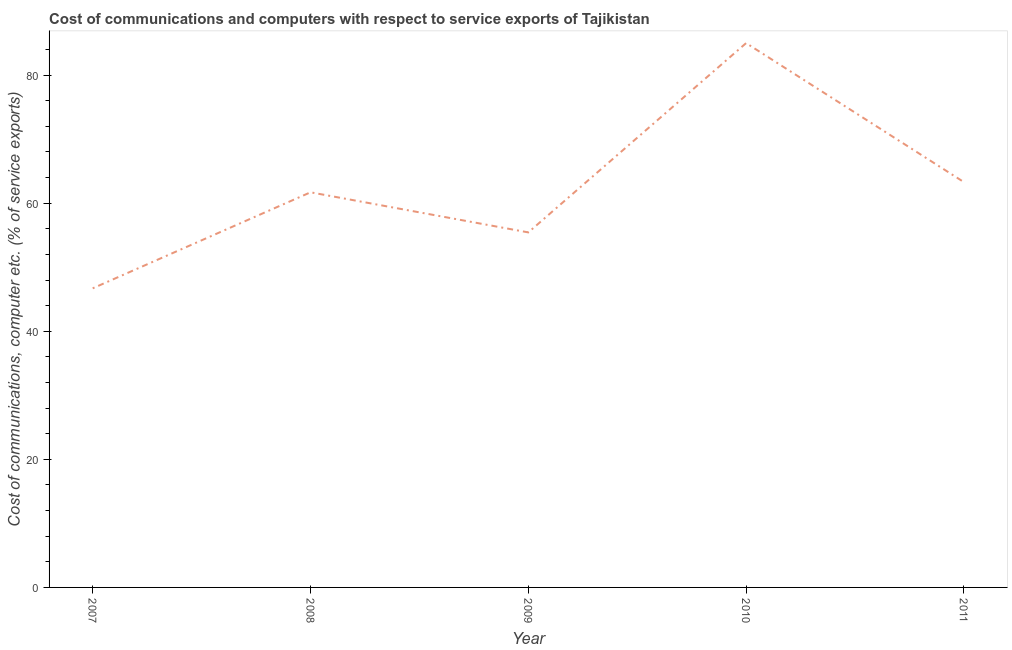What is the cost of communications and computer in 2010?
Keep it short and to the point. 84.99. Across all years, what is the maximum cost of communications and computer?
Your response must be concise. 84.99. Across all years, what is the minimum cost of communications and computer?
Make the answer very short. 46.7. In which year was the cost of communications and computer minimum?
Your answer should be compact. 2007. What is the sum of the cost of communications and computer?
Keep it short and to the point. 312.11. What is the difference between the cost of communications and computer in 2008 and 2010?
Offer a very short reply. -23.3. What is the average cost of communications and computer per year?
Your answer should be very brief. 62.42. What is the median cost of communications and computer?
Your answer should be very brief. 61.69. Do a majority of the years between 2011 and 2007 (inclusive) have cost of communications and computer greater than 12 %?
Make the answer very short. Yes. What is the ratio of the cost of communications and computer in 2007 to that in 2010?
Offer a terse response. 0.55. What is the difference between the highest and the second highest cost of communications and computer?
Your response must be concise. 21.71. Is the sum of the cost of communications and computer in 2008 and 2009 greater than the maximum cost of communications and computer across all years?
Give a very brief answer. Yes. What is the difference between the highest and the lowest cost of communications and computer?
Offer a terse response. 38.29. In how many years, is the cost of communications and computer greater than the average cost of communications and computer taken over all years?
Your response must be concise. 2. How many lines are there?
Give a very brief answer. 1. What is the difference between two consecutive major ticks on the Y-axis?
Make the answer very short. 20. Are the values on the major ticks of Y-axis written in scientific E-notation?
Make the answer very short. No. Does the graph contain any zero values?
Give a very brief answer. No. Does the graph contain grids?
Offer a very short reply. No. What is the title of the graph?
Your response must be concise. Cost of communications and computers with respect to service exports of Tajikistan. What is the label or title of the X-axis?
Your answer should be compact. Year. What is the label or title of the Y-axis?
Your answer should be compact. Cost of communications, computer etc. (% of service exports). What is the Cost of communications, computer etc. (% of service exports) in 2007?
Your answer should be very brief. 46.7. What is the Cost of communications, computer etc. (% of service exports) of 2008?
Provide a short and direct response. 61.69. What is the Cost of communications, computer etc. (% of service exports) in 2009?
Give a very brief answer. 55.43. What is the Cost of communications, computer etc. (% of service exports) in 2010?
Give a very brief answer. 84.99. What is the Cost of communications, computer etc. (% of service exports) of 2011?
Give a very brief answer. 63.28. What is the difference between the Cost of communications, computer etc. (% of service exports) in 2007 and 2008?
Give a very brief answer. -14.99. What is the difference between the Cost of communications, computer etc. (% of service exports) in 2007 and 2009?
Provide a short and direct response. -8.73. What is the difference between the Cost of communications, computer etc. (% of service exports) in 2007 and 2010?
Provide a succinct answer. -38.29. What is the difference between the Cost of communications, computer etc. (% of service exports) in 2007 and 2011?
Your response must be concise. -16.58. What is the difference between the Cost of communications, computer etc. (% of service exports) in 2008 and 2009?
Give a very brief answer. 6.26. What is the difference between the Cost of communications, computer etc. (% of service exports) in 2008 and 2010?
Your response must be concise. -23.3. What is the difference between the Cost of communications, computer etc. (% of service exports) in 2008 and 2011?
Make the answer very short. -1.59. What is the difference between the Cost of communications, computer etc. (% of service exports) in 2009 and 2010?
Give a very brief answer. -29.56. What is the difference between the Cost of communications, computer etc. (% of service exports) in 2009 and 2011?
Keep it short and to the point. -7.85. What is the difference between the Cost of communications, computer etc. (% of service exports) in 2010 and 2011?
Offer a terse response. 21.71. What is the ratio of the Cost of communications, computer etc. (% of service exports) in 2007 to that in 2008?
Your answer should be compact. 0.76. What is the ratio of the Cost of communications, computer etc. (% of service exports) in 2007 to that in 2009?
Provide a succinct answer. 0.84. What is the ratio of the Cost of communications, computer etc. (% of service exports) in 2007 to that in 2010?
Your answer should be compact. 0.55. What is the ratio of the Cost of communications, computer etc. (% of service exports) in 2007 to that in 2011?
Your answer should be compact. 0.74. What is the ratio of the Cost of communications, computer etc. (% of service exports) in 2008 to that in 2009?
Keep it short and to the point. 1.11. What is the ratio of the Cost of communications, computer etc. (% of service exports) in 2008 to that in 2010?
Offer a terse response. 0.73. What is the ratio of the Cost of communications, computer etc. (% of service exports) in 2008 to that in 2011?
Your response must be concise. 0.97. What is the ratio of the Cost of communications, computer etc. (% of service exports) in 2009 to that in 2010?
Provide a short and direct response. 0.65. What is the ratio of the Cost of communications, computer etc. (% of service exports) in 2009 to that in 2011?
Provide a succinct answer. 0.88. What is the ratio of the Cost of communications, computer etc. (% of service exports) in 2010 to that in 2011?
Give a very brief answer. 1.34. 